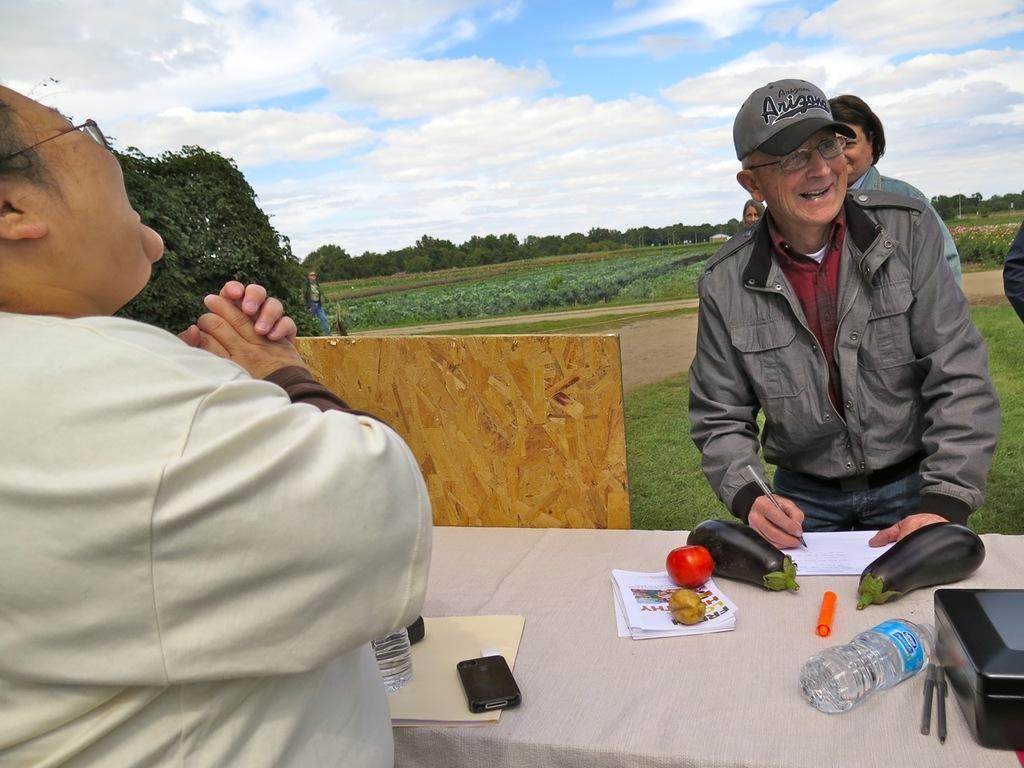In one or two sentences, can you explain what this image depicts? This is outside the city area. A person on the left is standing and smiling. On the right there are few people and he is wearing cap and smiling,he is writing something on the paper which is on the table. On the table we can see water bottle,brinjal,tomato,papers,mobile phone,etc. In the background we can see tree,and a field,sky with clouds. 